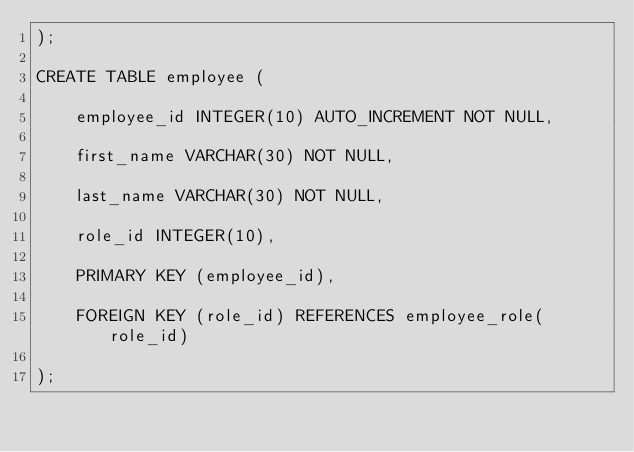<code> <loc_0><loc_0><loc_500><loc_500><_SQL_>);

CREATE TABLE employee (

    employee_id INTEGER(10) AUTO_INCREMENT NOT NULL,

    first_name VARCHAR(30) NOT NULL,

    last_name VARCHAR(30) NOT NULL,

    role_id INTEGER(10),

    PRIMARY KEY (employee_id),

    FOREIGN KEY (role_id) REFERENCES employee_role(role_id)

);
</code> 